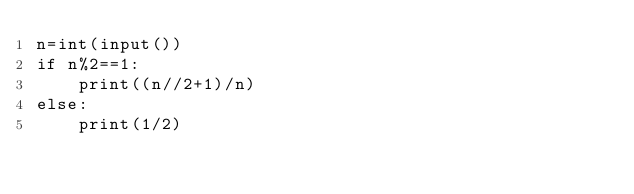<code> <loc_0><loc_0><loc_500><loc_500><_Python_>n=int(input())
if n%2==1:
    print((n//2+1)/n)
else:
    print(1/2)</code> 